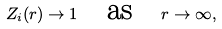Convert formula to latex. <formula><loc_0><loc_0><loc_500><loc_500>Z _ { i } ( r ) \to 1 \quad \text {as} \quad r \to \infty ,</formula> 